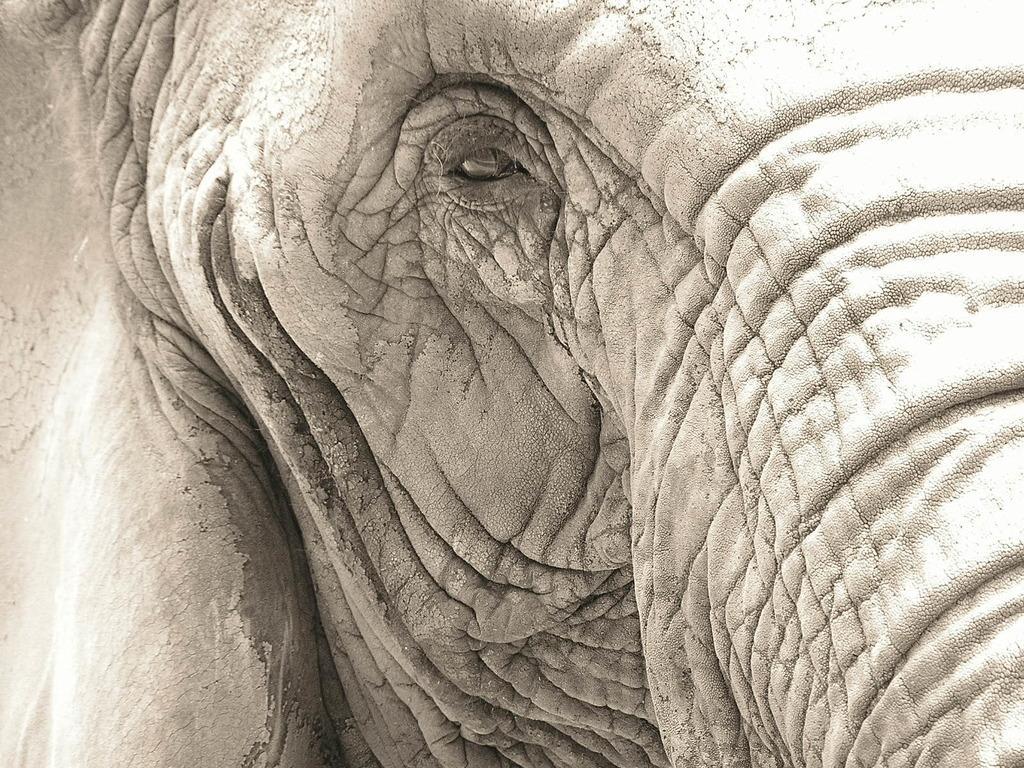In one or two sentences, can you explain what this image depicts? This image consists of an elephant. This image is taken may be during a day. 